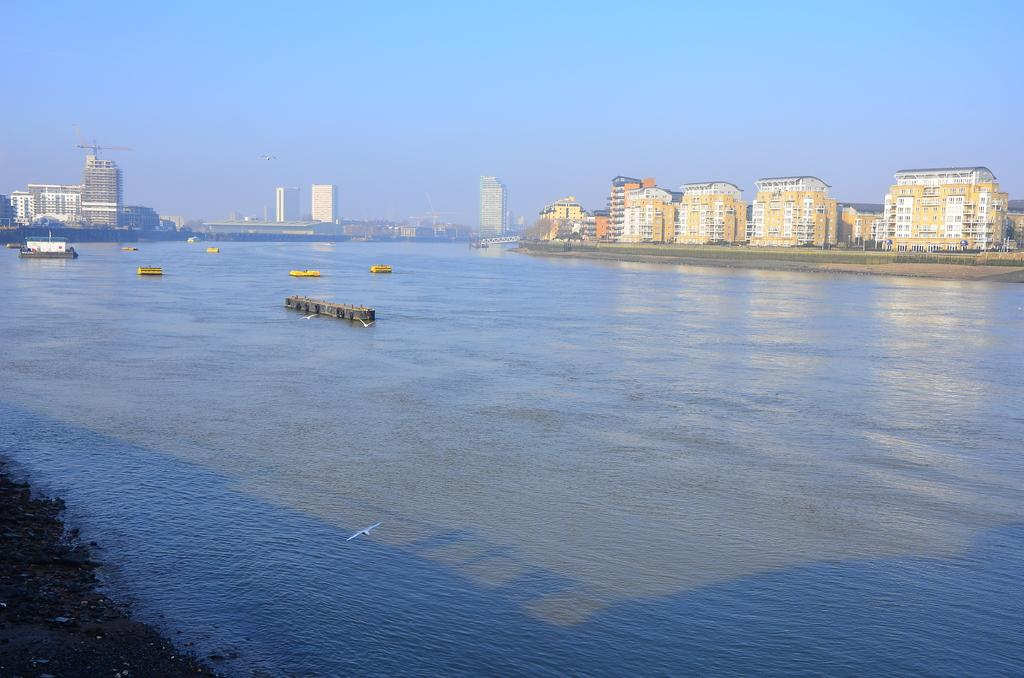What can be seen in the image? There are boats in the image. Where are the boats located? The boats are on the water. What else can be seen across the water? There are buildings visible on the other side of the water. What type of drum can be heard playing in the image? There is no drum present in the image, and therefore no sound can be heard. 